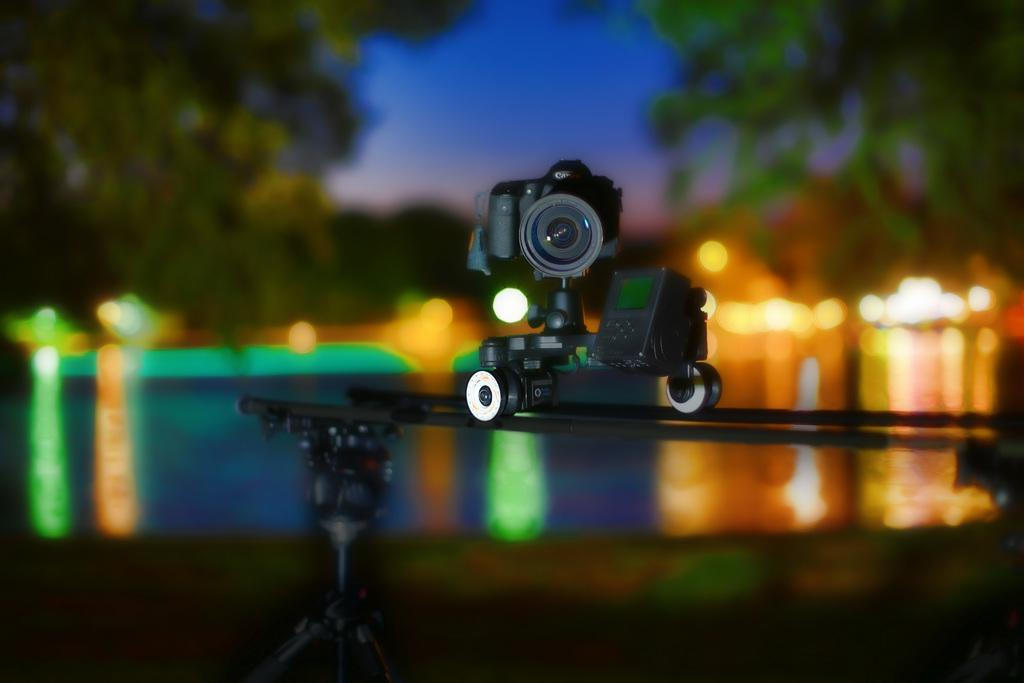What is the main object in the image? There is a camera on a stand in the image. Can you describe the background of the image? The background of the image is blurry. What color is the glove that is falling in the image? There is no glove present in the image, nor is there any object falling. 